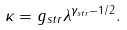Convert formula to latex. <formula><loc_0><loc_0><loc_500><loc_500>\kappa = g _ { s t r } \lambda ^ { \gamma _ { s t r } - 1 / 2 } .</formula> 